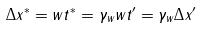Convert formula to latex. <formula><loc_0><loc_0><loc_500><loc_500>\Delta x ^ { * } = w t ^ { * } = \gamma _ { w } w t ^ { \prime } = \gamma _ { w } \Delta x ^ { \prime }</formula> 